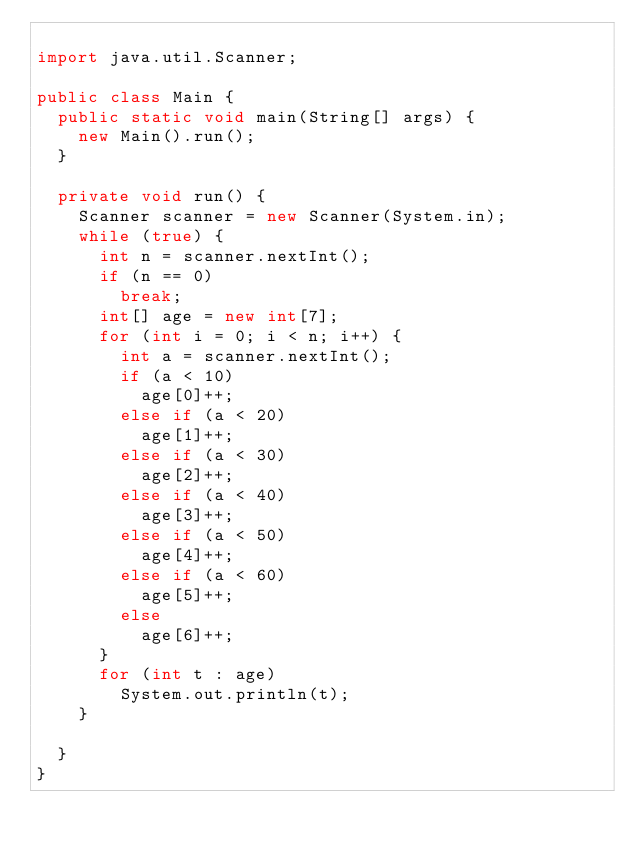<code> <loc_0><loc_0><loc_500><loc_500><_Java_>
import java.util.Scanner;

public class Main {
	public static void main(String[] args) {
		new Main().run();
	}

	private void run() {
		Scanner scanner = new Scanner(System.in);
		while (true) {
			int n = scanner.nextInt();
			if (n == 0)
				break;
			int[] age = new int[7];
			for (int i = 0; i < n; i++) {
				int a = scanner.nextInt();
				if (a < 10)
					age[0]++;
				else if (a < 20)
					age[1]++;
				else if (a < 30)
					age[2]++;
				else if (a < 40)
					age[3]++;
				else if (a < 50)
					age[4]++;
				else if (a < 60)
					age[5]++;
				else
					age[6]++;
			}
			for (int t : age)
				System.out.println(t);
		}

	}
}</code> 